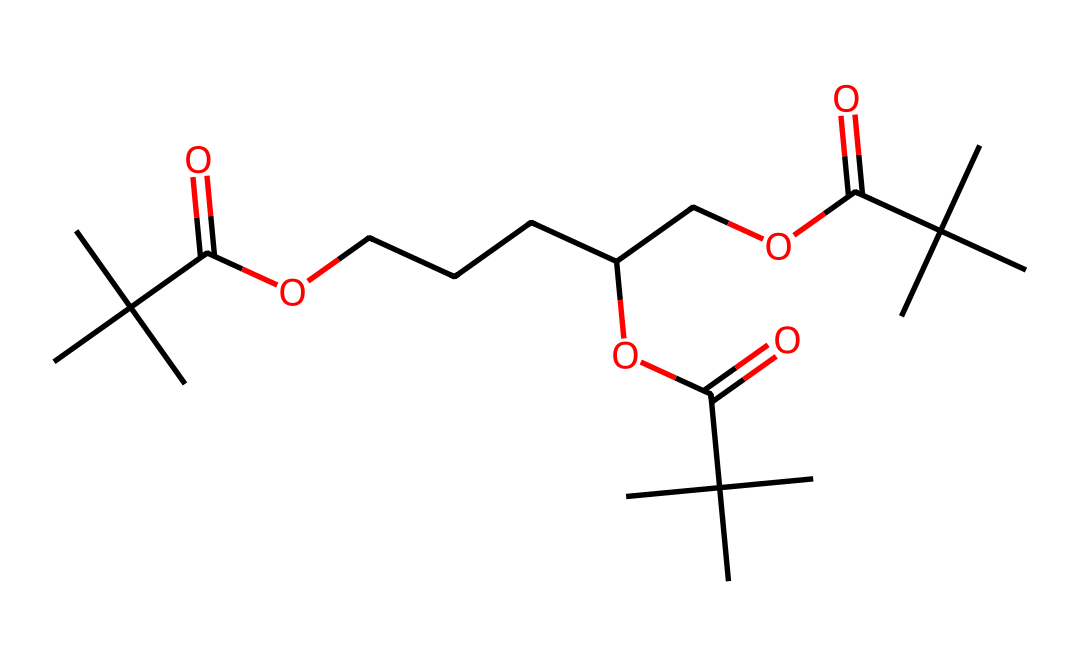What is the total number of carbon atoms in this polymer structure? To find the number of carbon atoms, we can count the 'C' occurrences in the provided SMILES notation. Each 'C' represents a carbon atom. After counting, we find that there are 17 carbon atoms.
Answer: 17 How many ester functional groups are present in this chemical structure? An ester functional group is indicated by the presence of -COO- in the structure. By analyzing the SMILES representation, we can find three occurrences of such groups, indicating the presence of three ester functional groups.
Answer: 3 What type of polymer is represented by this chemical? The structure suggests a polymer made from ester linkages, indicating it is a type of polyester, which is formed by the reaction of alcohols with carboxylic acids. The repeated -COO- link confirms this classification.
Answer: polyester What is the degree of branching in the structure? The structure has multiple tert-butyl groups, which are branched side chains attached to the main chain. This indicates a high degree of branching; visually, we can confirm several branched areas within the structure, confirming that it is highly branched.
Answer: high How many different types of functional groups can be identified in this polymer? In analyzing the SMILES, we can identify at least two different types of functional groups: carboxylic acids (due to the -COOH structure) and esters (represented by -COO-). Counting gives us two distinct functional groups.
Answer: 2 